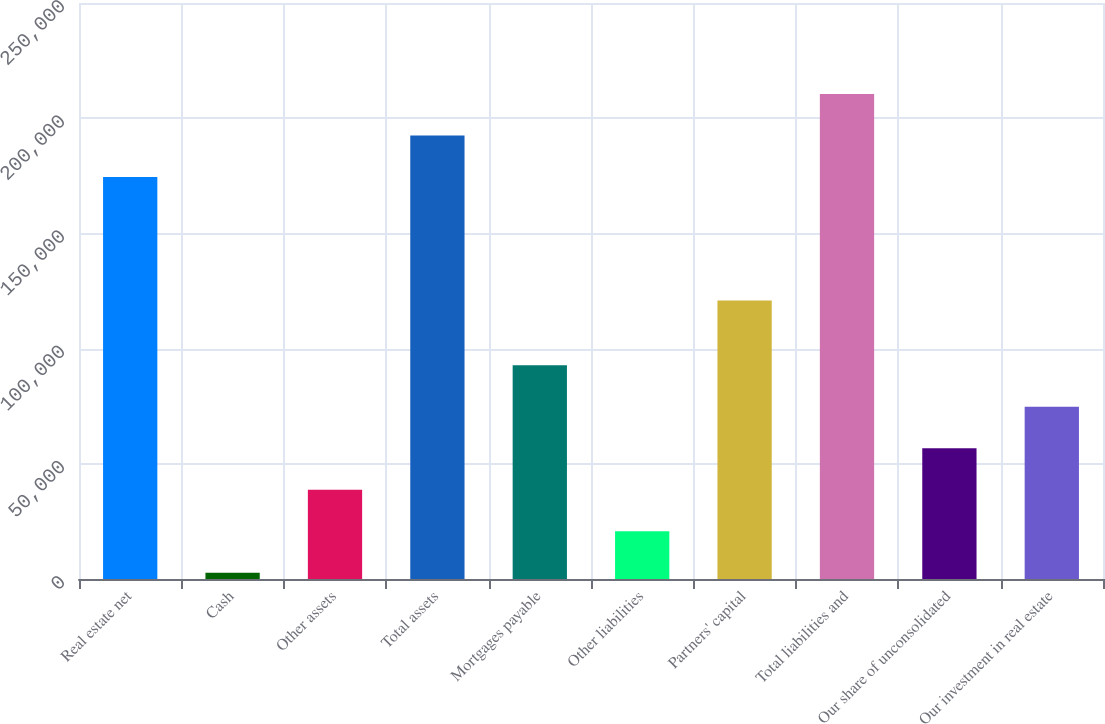Convert chart to OTSL. <chart><loc_0><loc_0><loc_500><loc_500><bar_chart><fcel>Real estate net<fcel>Cash<fcel>Other assets<fcel>Total assets<fcel>Mortgages payable<fcel>Other liabilities<fcel>Partners' capital<fcel>Total liabilities and<fcel>Our share of unconsolidated<fcel>Our investment in real estate<nl><fcel>174509<fcel>2735<fcel>38744<fcel>192514<fcel>92757.5<fcel>20739.5<fcel>120854<fcel>210518<fcel>56748.5<fcel>74753<nl></chart> 